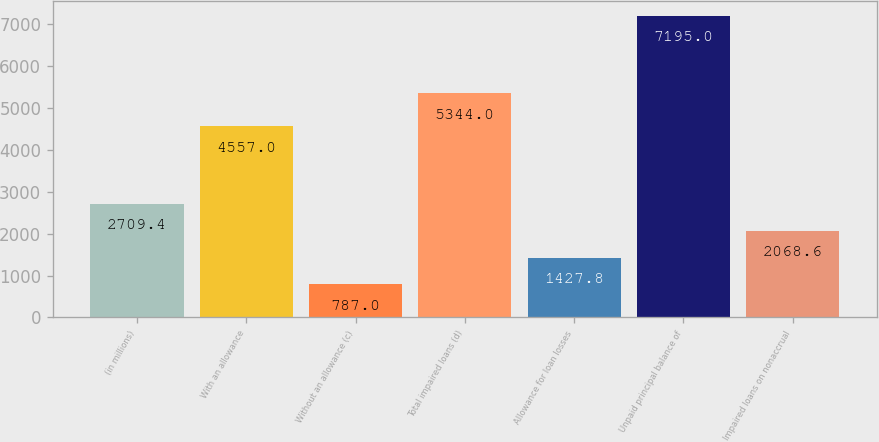<chart> <loc_0><loc_0><loc_500><loc_500><bar_chart><fcel>(in millions)<fcel>With an allowance<fcel>Without an allowance (c)<fcel>Total impaired loans (d)<fcel>Allowance for loan losses<fcel>Unpaid principal balance of<fcel>Impaired loans on nonaccrual<nl><fcel>2709.4<fcel>4557<fcel>787<fcel>5344<fcel>1427.8<fcel>7195<fcel>2068.6<nl></chart> 